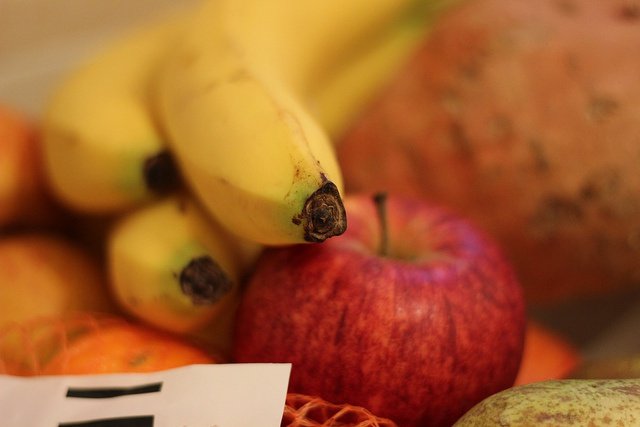Describe the objects in this image and their specific colors. I can see banana in tan, orange, olive, and maroon tones, apple in tan, brown, maroon, and red tones, orange in tan, red, brown, and maroon tones, orange in tan, red, brown, and maroon tones, and orange in tan, red, and maroon tones in this image. 